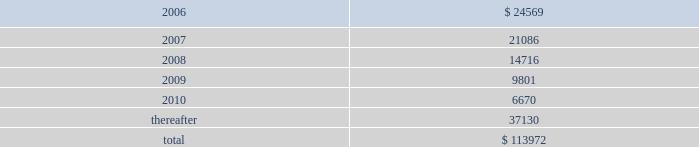Packaging corporation of america notes to consolidated financial statements ( continued ) december 31 , 2005 9 .
Shareholders 2019 equity ( continued ) stockholder received proceeds , net of the underwriting discount , of $ 20.69 per share .
The company did not sell any shares in , or receive any proceeds from , the secondary offering .
Concurrent with the closing of the secondary offering on december 21 , 2005 , the company entered into a common stock repurchase agreement with pca holdings llc .
Pursuant to the repurchase agreement , the company purchased 4500000 shares of common stock directly from pca holdings llc at the initial price to the public net of the underwriting discount or $ 20.69 per share , the same net price per share received by pca holdings llc in the secondary offering .
These shares were retired on december 21 , 2005 .
10 .
Commitments and contingencies capital commitments the company had authorized capital expenditures of approximately $ 33.1 million and $ 55.2 million as of december 31 , 2005 and 2004 , respectively , in connection with the expansion and replacement of existing facilities and equipment .
Operating leases pca leases space for certain of its facilities and cutting rights to approximately 108000 acres of timberland under long-term leases .
The company also leases equipment , primarily vehicles and rolling stock , and other assets under long-term leases of a duration generally of three years .
The minimum lease payments under non-cancelable operating leases with lease terms in excess of one year are as follows : ( in thousands ) .
Capital lease obligations were not significant to the accompanying financial statements .
Total lease expense , including base rent on all leases and executory costs , such as insurance , taxes , and maintenance , for the years ended december 31 , 2005 , 2004 and 2003 was $ 35.8 million , $ 33.0 million and $ 31.6 million , respectively .
These costs are included in cost of goods sold and selling and administrative expenses. .
What was the percentage change in total lease expense , including base rent on all leases and executory costs , such as insurance , taxes , and maintenance from 2004 to 2005? 
Computations: ((35.8 - 33.0) / 33.0)
Answer: 0.08485. 